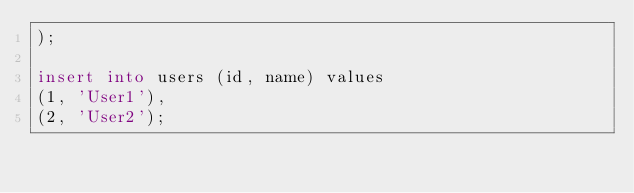Convert code to text. <code><loc_0><loc_0><loc_500><loc_500><_SQL_>);

insert into users (id, name) values
(1, 'User1'),
(2, 'User2');
</code> 